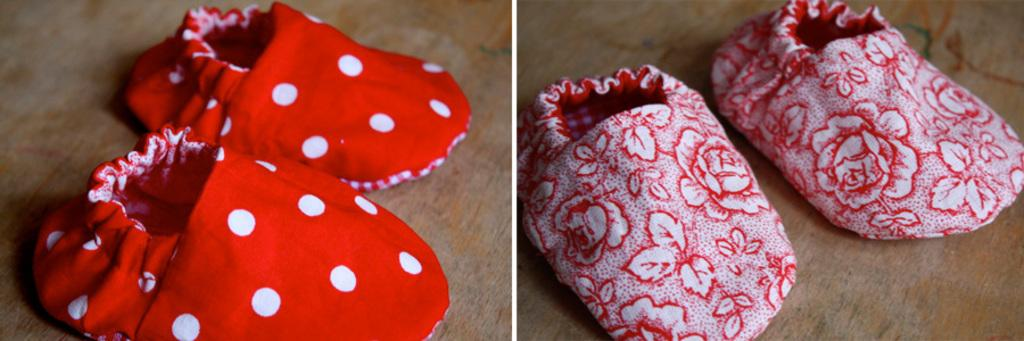How many images are present in the image? The image consists of two images. What objects are featured in the images? There are two pairs of shoes in the images. What can be inferred about the size of the shoes? The shoes are of small size. How many doors can be seen in the image? There are no doors present in the image; it features two pairs of small shoes. Can you describe the romantic interaction between the shoes in the image? There is no romantic interaction depicted in the image; it simply shows two pairs of small shoes. 